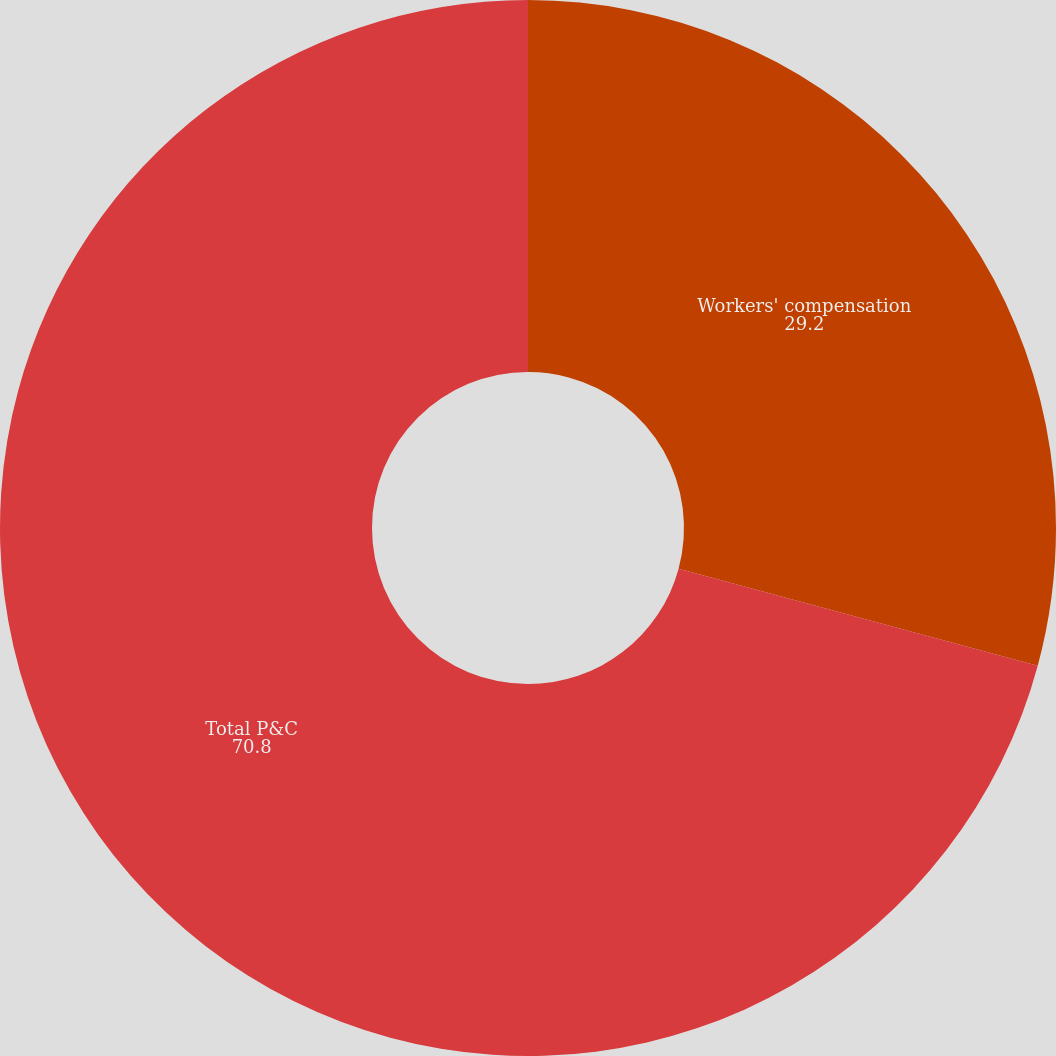Convert chart to OTSL. <chart><loc_0><loc_0><loc_500><loc_500><pie_chart><fcel>Workers' compensation<fcel>Total P&C<nl><fcel>29.2%<fcel>70.8%<nl></chart> 